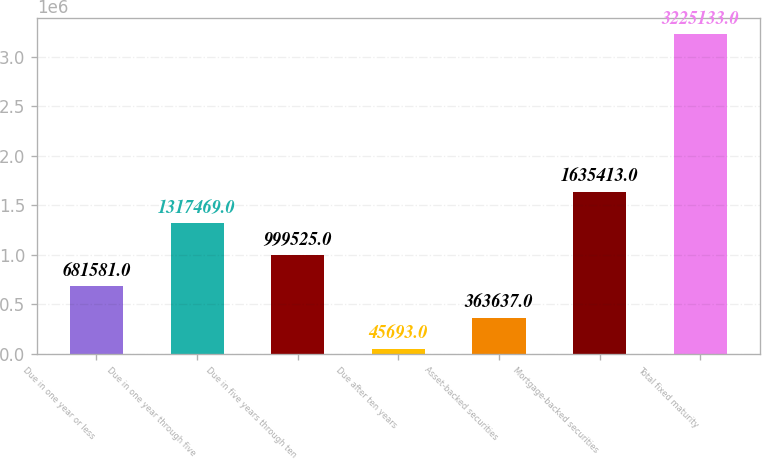Convert chart to OTSL. <chart><loc_0><loc_0><loc_500><loc_500><bar_chart><fcel>Due in one year or less<fcel>Due in one year through five<fcel>Due in five years through ten<fcel>Due after ten years<fcel>Asset-backed securities<fcel>Mortgage-backed securities<fcel>Total fixed maturity<nl><fcel>681581<fcel>1.31747e+06<fcel>999525<fcel>45693<fcel>363637<fcel>1.63541e+06<fcel>3.22513e+06<nl></chart> 